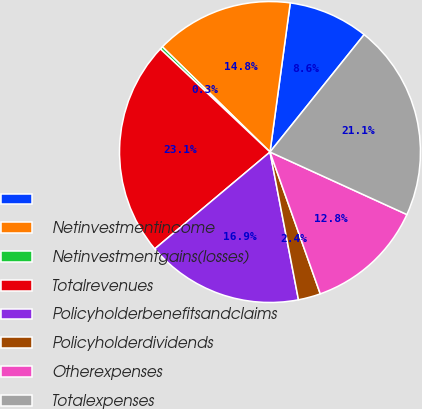Convert chart. <chart><loc_0><loc_0><loc_500><loc_500><pie_chart><ecel><fcel>Netinvestmentincome<fcel>Netinvestmentgains(losses)<fcel>Totalrevenues<fcel>Policyholderbenefitsandclaims<fcel>Policyholderdividends<fcel>Otherexpenses<fcel>Totalexpenses<nl><fcel>8.61%<fcel>14.83%<fcel>0.31%<fcel>23.13%<fcel>16.91%<fcel>2.39%<fcel>12.76%<fcel>21.06%<nl></chart> 